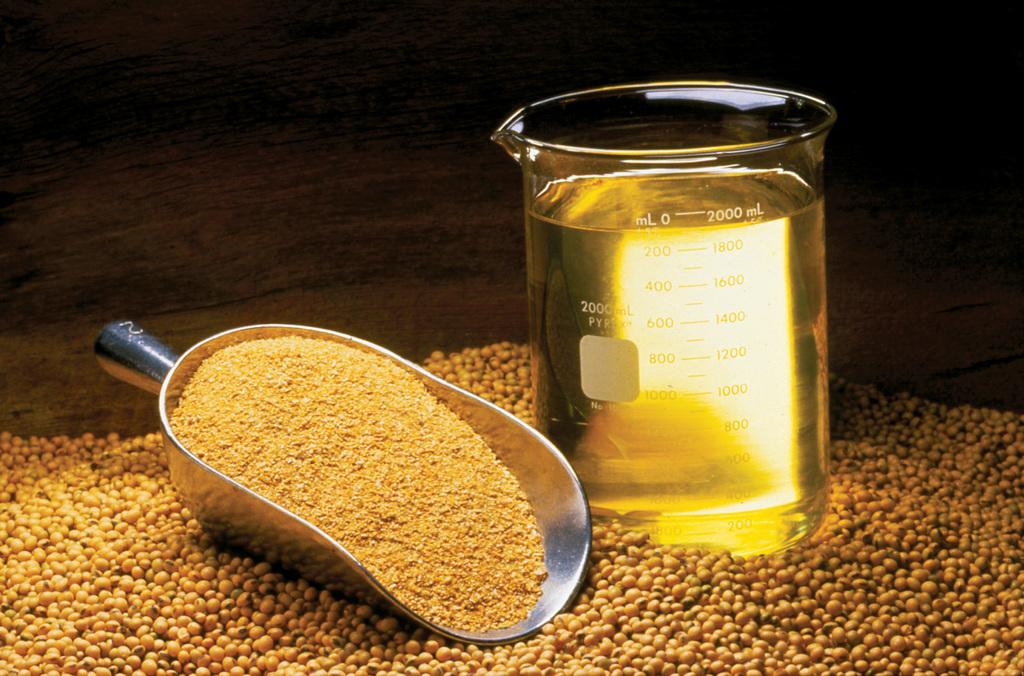What does the measuring cup go up to?
Make the answer very short. 2000ml. 